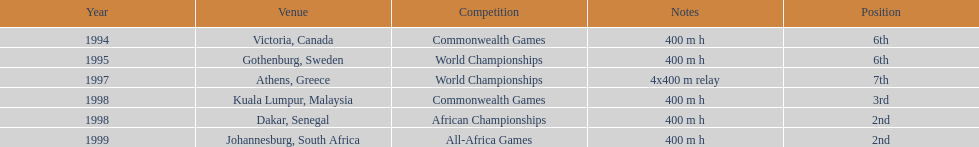What is the last competition on the chart? All-Africa Games. 